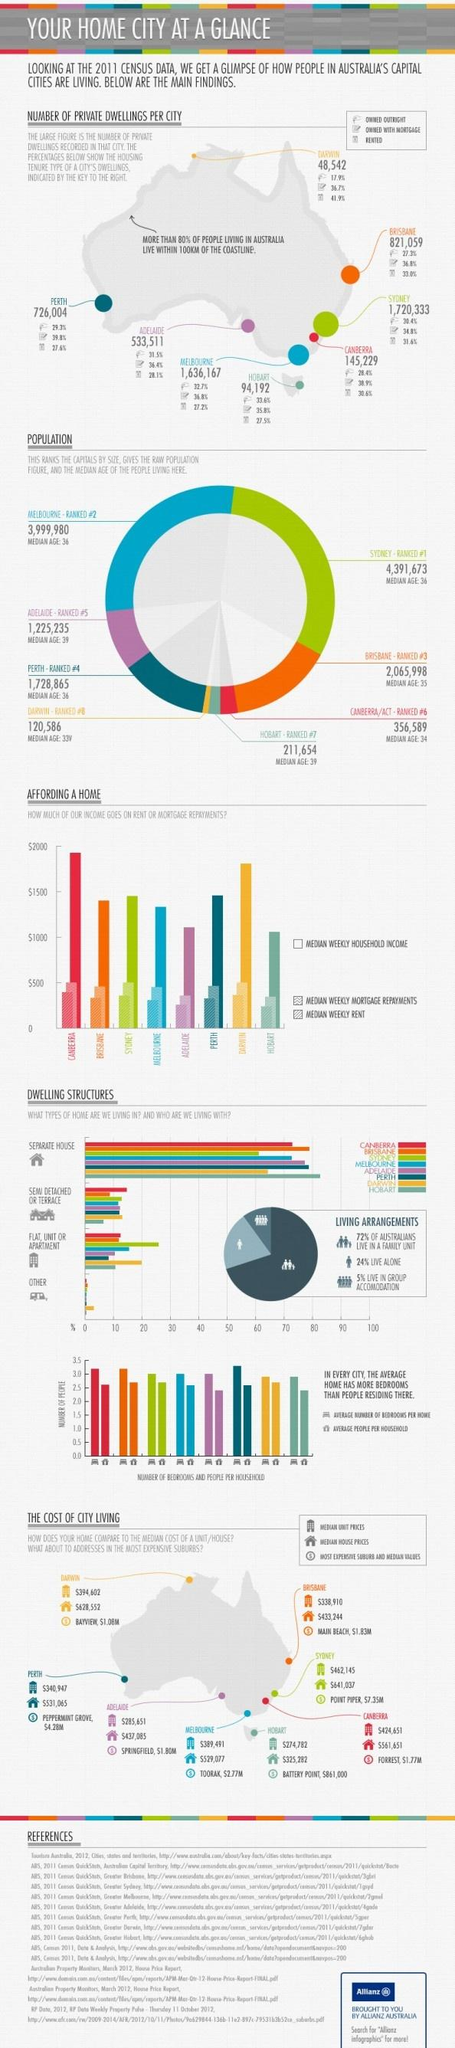Identify some key points in this picture. According to the given data, 95% of respondents do not live in group accommodation. According to a recent survey, 28% of Australians do not live in a family unit. Seventy-six percent of people do not live alone. 